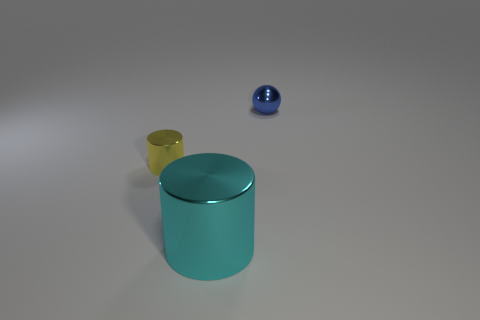Are there an equal number of cyan objects that are behind the small blue sphere and tiny brown objects?
Your answer should be very brief. Yes. Is there anything else that is the same size as the yellow metal cylinder?
Your response must be concise. Yes. There is another shiny thing that is the same shape as the yellow metallic thing; what is its color?
Give a very brief answer. Cyan. What number of tiny yellow shiny objects have the same shape as the small blue thing?
Offer a very short reply. 0. How many large gray cubes are there?
Ensure brevity in your answer.  0. Is there a small yellow thing made of the same material as the blue thing?
Give a very brief answer. Yes. There is a metal thing that is behind the small yellow cylinder; is it the same size as the metal cylinder that is on the left side of the large cyan cylinder?
Ensure brevity in your answer.  Yes. How big is the metal thing in front of the tiny yellow metal object?
Your answer should be compact. Large. There is a small shiny object left of the ball; are there any small cylinders that are in front of it?
Give a very brief answer. No. Does the blue ball have the same size as the cylinder that is on the left side of the cyan metallic cylinder?
Provide a short and direct response. Yes. 